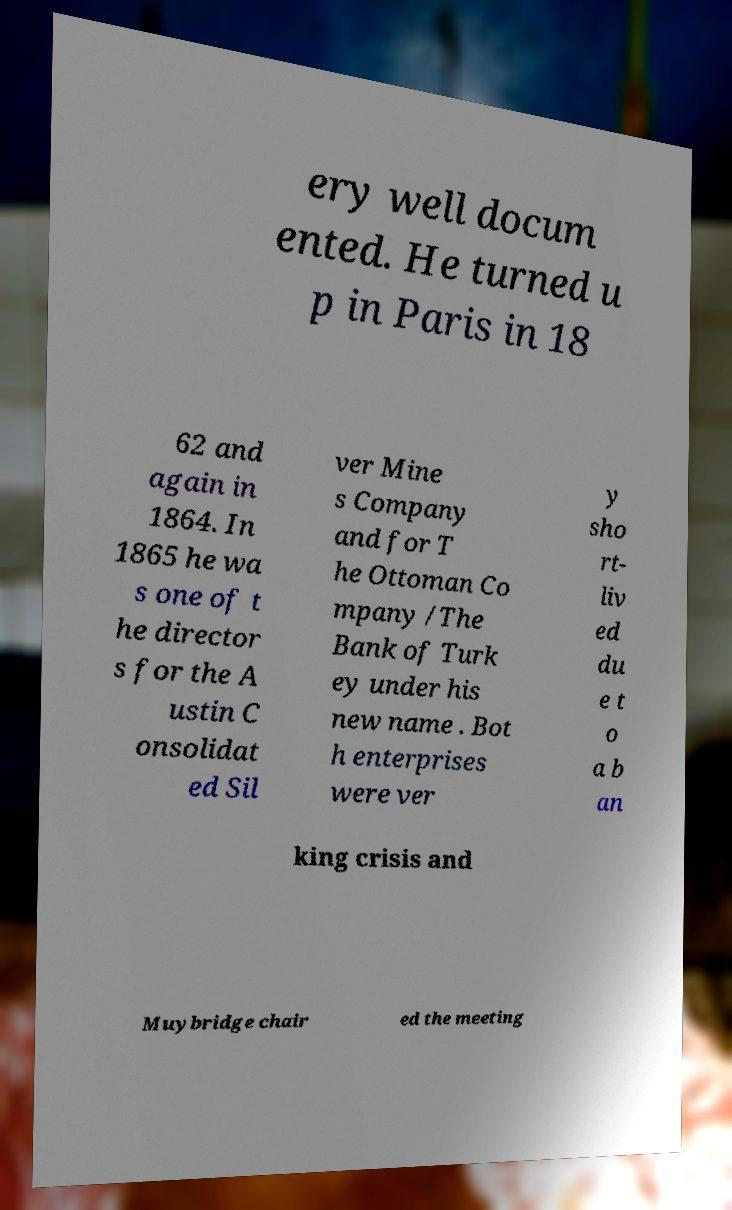For documentation purposes, I need the text within this image transcribed. Could you provide that? ery well docum ented. He turned u p in Paris in 18 62 and again in 1864. In 1865 he wa s one of t he director s for the A ustin C onsolidat ed Sil ver Mine s Company and for T he Ottoman Co mpany /The Bank of Turk ey under his new name . Bot h enterprises were ver y sho rt- liv ed du e t o a b an king crisis and Muybridge chair ed the meeting 